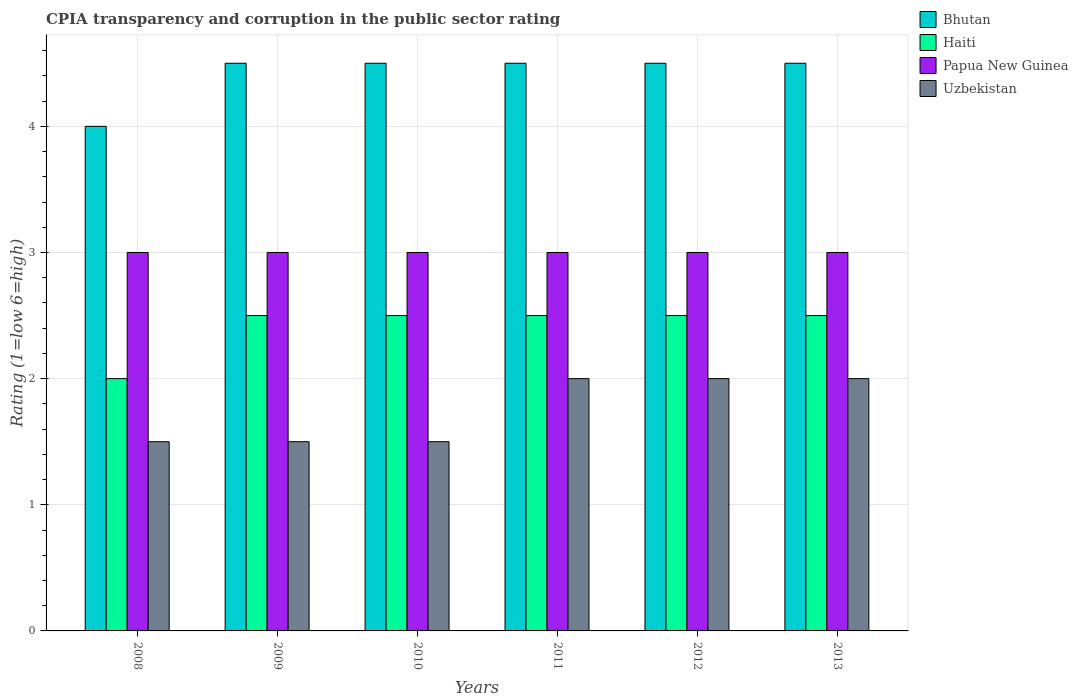How many groups of bars are there?
Provide a short and direct response. 6. Are the number of bars per tick equal to the number of legend labels?
Offer a very short reply. Yes. Are the number of bars on each tick of the X-axis equal?
Your answer should be very brief. Yes. How many bars are there on the 2nd tick from the left?
Provide a succinct answer. 4. How many bars are there on the 2nd tick from the right?
Your answer should be compact. 4. What is the label of the 2nd group of bars from the left?
Offer a terse response. 2009. In how many cases, is the number of bars for a given year not equal to the number of legend labels?
Ensure brevity in your answer.  0. What is the CPIA rating in Haiti in 2011?
Ensure brevity in your answer.  2.5. Across all years, what is the maximum CPIA rating in Bhutan?
Keep it short and to the point. 4.5. What is the total CPIA rating in Bhutan in the graph?
Ensure brevity in your answer.  26.5. What is the difference between the CPIA rating in Uzbekistan in 2011 and the CPIA rating in Bhutan in 2008?
Your response must be concise. -2. What is the average CPIA rating in Haiti per year?
Offer a very short reply. 2.42. In the year 2013, what is the difference between the CPIA rating in Bhutan and CPIA rating in Uzbekistan?
Give a very brief answer. 2.5. Is the CPIA rating in Haiti in 2011 less than that in 2013?
Offer a very short reply. No. What is the difference between the highest and the second highest CPIA rating in Uzbekistan?
Provide a succinct answer. 0. What is the difference between the highest and the lowest CPIA rating in Uzbekistan?
Ensure brevity in your answer.  0.5. In how many years, is the CPIA rating in Bhutan greater than the average CPIA rating in Bhutan taken over all years?
Provide a succinct answer. 5. What does the 1st bar from the left in 2012 represents?
Provide a short and direct response. Bhutan. What does the 3rd bar from the right in 2013 represents?
Your answer should be very brief. Haiti. Is it the case that in every year, the sum of the CPIA rating in Papua New Guinea and CPIA rating in Uzbekistan is greater than the CPIA rating in Haiti?
Offer a very short reply. Yes. How many bars are there?
Your response must be concise. 24. Does the graph contain any zero values?
Your response must be concise. No. Where does the legend appear in the graph?
Offer a terse response. Top right. What is the title of the graph?
Give a very brief answer. CPIA transparency and corruption in the public sector rating. What is the label or title of the Y-axis?
Make the answer very short. Rating (1=low 6=high). What is the Rating (1=low 6=high) of Bhutan in 2008?
Provide a succinct answer. 4. What is the Rating (1=low 6=high) of Haiti in 2008?
Make the answer very short. 2. What is the Rating (1=low 6=high) of Papua New Guinea in 2008?
Give a very brief answer. 3. What is the Rating (1=low 6=high) in Uzbekistan in 2008?
Offer a very short reply. 1.5. What is the Rating (1=low 6=high) of Bhutan in 2009?
Give a very brief answer. 4.5. What is the Rating (1=low 6=high) in Haiti in 2009?
Ensure brevity in your answer.  2.5. What is the Rating (1=low 6=high) of Papua New Guinea in 2009?
Offer a very short reply. 3. What is the Rating (1=low 6=high) of Uzbekistan in 2009?
Your answer should be very brief. 1.5. What is the Rating (1=low 6=high) in Papua New Guinea in 2010?
Your answer should be very brief. 3. What is the Rating (1=low 6=high) in Bhutan in 2011?
Give a very brief answer. 4.5. What is the Rating (1=low 6=high) in Haiti in 2011?
Your answer should be compact. 2.5. What is the Rating (1=low 6=high) in Bhutan in 2013?
Offer a very short reply. 4.5. What is the Rating (1=low 6=high) in Haiti in 2013?
Offer a very short reply. 2.5. Across all years, what is the maximum Rating (1=low 6=high) in Bhutan?
Provide a succinct answer. 4.5. Across all years, what is the maximum Rating (1=low 6=high) of Haiti?
Your answer should be compact. 2.5. Across all years, what is the maximum Rating (1=low 6=high) of Papua New Guinea?
Your answer should be compact. 3. Across all years, what is the minimum Rating (1=low 6=high) in Papua New Guinea?
Offer a terse response. 3. What is the total Rating (1=low 6=high) in Bhutan in the graph?
Ensure brevity in your answer.  26.5. What is the total Rating (1=low 6=high) in Papua New Guinea in the graph?
Offer a terse response. 18. What is the difference between the Rating (1=low 6=high) in Haiti in 2008 and that in 2009?
Ensure brevity in your answer.  -0.5. What is the difference between the Rating (1=low 6=high) in Uzbekistan in 2008 and that in 2009?
Provide a succinct answer. 0. What is the difference between the Rating (1=low 6=high) of Papua New Guinea in 2008 and that in 2010?
Offer a very short reply. 0. What is the difference between the Rating (1=low 6=high) in Uzbekistan in 2008 and that in 2010?
Keep it short and to the point. 0. What is the difference between the Rating (1=low 6=high) in Bhutan in 2008 and that in 2011?
Provide a succinct answer. -0.5. What is the difference between the Rating (1=low 6=high) in Haiti in 2008 and that in 2011?
Provide a short and direct response. -0.5. What is the difference between the Rating (1=low 6=high) in Haiti in 2008 and that in 2012?
Offer a very short reply. -0.5. What is the difference between the Rating (1=low 6=high) of Papua New Guinea in 2009 and that in 2010?
Make the answer very short. 0. What is the difference between the Rating (1=low 6=high) of Haiti in 2009 and that in 2011?
Keep it short and to the point. 0. What is the difference between the Rating (1=low 6=high) of Papua New Guinea in 2009 and that in 2011?
Ensure brevity in your answer.  0. What is the difference between the Rating (1=low 6=high) of Uzbekistan in 2009 and that in 2011?
Your answer should be very brief. -0.5. What is the difference between the Rating (1=low 6=high) in Bhutan in 2009 and that in 2012?
Ensure brevity in your answer.  0. What is the difference between the Rating (1=low 6=high) in Haiti in 2009 and that in 2012?
Offer a very short reply. 0. What is the difference between the Rating (1=low 6=high) of Papua New Guinea in 2009 and that in 2012?
Your answer should be very brief. 0. What is the difference between the Rating (1=low 6=high) of Bhutan in 2010 and that in 2011?
Your answer should be very brief. 0. What is the difference between the Rating (1=low 6=high) of Haiti in 2010 and that in 2011?
Your answer should be compact. 0. What is the difference between the Rating (1=low 6=high) of Uzbekistan in 2010 and that in 2011?
Provide a short and direct response. -0.5. What is the difference between the Rating (1=low 6=high) in Bhutan in 2010 and that in 2012?
Make the answer very short. 0. What is the difference between the Rating (1=low 6=high) in Uzbekistan in 2010 and that in 2012?
Offer a terse response. -0.5. What is the difference between the Rating (1=low 6=high) of Haiti in 2010 and that in 2013?
Your response must be concise. 0. What is the difference between the Rating (1=low 6=high) in Papua New Guinea in 2010 and that in 2013?
Your answer should be very brief. 0. What is the difference between the Rating (1=low 6=high) in Uzbekistan in 2010 and that in 2013?
Ensure brevity in your answer.  -0.5. What is the difference between the Rating (1=low 6=high) of Bhutan in 2011 and that in 2012?
Provide a short and direct response. 0. What is the difference between the Rating (1=low 6=high) of Haiti in 2011 and that in 2012?
Ensure brevity in your answer.  0. What is the difference between the Rating (1=low 6=high) in Uzbekistan in 2011 and that in 2012?
Give a very brief answer. 0. What is the difference between the Rating (1=low 6=high) in Bhutan in 2011 and that in 2013?
Offer a very short reply. 0. What is the difference between the Rating (1=low 6=high) in Haiti in 2011 and that in 2013?
Give a very brief answer. 0. What is the difference between the Rating (1=low 6=high) in Bhutan in 2012 and that in 2013?
Your answer should be compact. 0. What is the difference between the Rating (1=low 6=high) of Papua New Guinea in 2012 and that in 2013?
Your answer should be very brief. 0. What is the difference between the Rating (1=low 6=high) in Uzbekistan in 2012 and that in 2013?
Ensure brevity in your answer.  0. What is the difference between the Rating (1=low 6=high) of Bhutan in 2008 and the Rating (1=low 6=high) of Haiti in 2009?
Your answer should be very brief. 1.5. What is the difference between the Rating (1=low 6=high) of Bhutan in 2008 and the Rating (1=low 6=high) of Papua New Guinea in 2009?
Provide a succinct answer. 1. What is the difference between the Rating (1=low 6=high) in Haiti in 2008 and the Rating (1=low 6=high) in Papua New Guinea in 2009?
Make the answer very short. -1. What is the difference between the Rating (1=low 6=high) of Papua New Guinea in 2008 and the Rating (1=low 6=high) of Uzbekistan in 2009?
Ensure brevity in your answer.  1.5. What is the difference between the Rating (1=low 6=high) of Papua New Guinea in 2008 and the Rating (1=low 6=high) of Uzbekistan in 2010?
Keep it short and to the point. 1.5. What is the difference between the Rating (1=low 6=high) of Bhutan in 2008 and the Rating (1=low 6=high) of Uzbekistan in 2011?
Your answer should be very brief. 2. What is the difference between the Rating (1=low 6=high) in Papua New Guinea in 2008 and the Rating (1=low 6=high) in Uzbekistan in 2011?
Keep it short and to the point. 1. What is the difference between the Rating (1=low 6=high) in Bhutan in 2008 and the Rating (1=low 6=high) in Papua New Guinea in 2012?
Make the answer very short. 1. What is the difference between the Rating (1=low 6=high) in Bhutan in 2008 and the Rating (1=low 6=high) in Uzbekistan in 2012?
Offer a very short reply. 2. What is the difference between the Rating (1=low 6=high) of Haiti in 2008 and the Rating (1=low 6=high) of Papua New Guinea in 2012?
Your response must be concise. -1. What is the difference between the Rating (1=low 6=high) of Haiti in 2008 and the Rating (1=low 6=high) of Uzbekistan in 2012?
Offer a very short reply. 0. What is the difference between the Rating (1=low 6=high) of Papua New Guinea in 2008 and the Rating (1=low 6=high) of Uzbekistan in 2012?
Provide a succinct answer. 1. What is the difference between the Rating (1=low 6=high) of Bhutan in 2008 and the Rating (1=low 6=high) of Papua New Guinea in 2013?
Keep it short and to the point. 1. What is the difference between the Rating (1=low 6=high) of Papua New Guinea in 2008 and the Rating (1=low 6=high) of Uzbekistan in 2013?
Provide a short and direct response. 1. What is the difference between the Rating (1=low 6=high) of Bhutan in 2009 and the Rating (1=low 6=high) of Haiti in 2010?
Your response must be concise. 2. What is the difference between the Rating (1=low 6=high) of Bhutan in 2009 and the Rating (1=low 6=high) of Papua New Guinea in 2010?
Offer a very short reply. 1.5. What is the difference between the Rating (1=low 6=high) of Bhutan in 2009 and the Rating (1=low 6=high) of Uzbekistan in 2010?
Your response must be concise. 3. What is the difference between the Rating (1=low 6=high) of Haiti in 2009 and the Rating (1=low 6=high) of Uzbekistan in 2010?
Offer a very short reply. 1. What is the difference between the Rating (1=low 6=high) of Bhutan in 2009 and the Rating (1=low 6=high) of Haiti in 2011?
Your answer should be compact. 2. What is the difference between the Rating (1=low 6=high) in Haiti in 2009 and the Rating (1=low 6=high) in Papua New Guinea in 2011?
Offer a terse response. -0.5. What is the difference between the Rating (1=low 6=high) in Haiti in 2009 and the Rating (1=low 6=high) in Uzbekistan in 2012?
Your response must be concise. 0.5. What is the difference between the Rating (1=low 6=high) of Bhutan in 2009 and the Rating (1=low 6=high) of Uzbekistan in 2013?
Your response must be concise. 2.5. What is the difference between the Rating (1=low 6=high) of Papua New Guinea in 2009 and the Rating (1=low 6=high) of Uzbekistan in 2013?
Your answer should be compact. 1. What is the difference between the Rating (1=low 6=high) of Bhutan in 2010 and the Rating (1=low 6=high) of Haiti in 2011?
Make the answer very short. 2. What is the difference between the Rating (1=low 6=high) in Haiti in 2010 and the Rating (1=low 6=high) in Papua New Guinea in 2011?
Make the answer very short. -0.5. What is the difference between the Rating (1=low 6=high) in Haiti in 2010 and the Rating (1=low 6=high) in Uzbekistan in 2011?
Offer a very short reply. 0.5. What is the difference between the Rating (1=low 6=high) in Papua New Guinea in 2010 and the Rating (1=low 6=high) in Uzbekistan in 2011?
Your answer should be compact. 1. What is the difference between the Rating (1=low 6=high) of Bhutan in 2010 and the Rating (1=low 6=high) of Haiti in 2012?
Your answer should be compact. 2. What is the difference between the Rating (1=low 6=high) of Haiti in 2010 and the Rating (1=low 6=high) of Uzbekistan in 2012?
Provide a succinct answer. 0.5. What is the difference between the Rating (1=low 6=high) of Bhutan in 2010 and the Rating (1=low 6=high) of Haiti in 2013?
Make the answer very short. 2. What is the difference between the Rating (1=low 6=high) of Haiti in 2010 and the Rating (1=low 6=high) of Papua New Guinea in 2013?
Provide a succinct answer. -0.5. What is the difference between the Rating (1=low 6=high) of Haiti in 2010 and the Rating (1=low 6=high) of Uzbekistan in 2013?
Provide a short and direct response. 0.5. What is the difference between the Rating (1=low 6=high) in Papua New Guinea in 2010 and the Rating (1=low 6=high) in Uzbekistan in 2013?
Keep it short and to the point. 1. What is the difference between the Rating (1=low 6=high) in Bhutan in 2011 and the Rating (1=low 6=high) in Haiti in 2012?
Your answer should be very brief. 2. What is the difference between the Rating (1=low 6=high) of Haiti in 2011 and the Rating (1=low 6=high) of Papua New Guinea in 2012?
Offer a terse response. -0.5. What is the difference between the Rating (1=low 6=high) of Papua New Guinea in 2011 and the Rating (1=low 6=high) of Uzbekistan in 2012?
Provide a succinct answer. 1. What is the difference between the Rating (1=low 6=high) of Bhutan in 2011 and the Rating (1=low 6=high) of Papua New Guinea in 2013?
Your answer should be very brief. 1.5. What is the difference between the Rating (1=low 6=high) of Haiti in 2011 and the Rating (1=low 6=high) of Papua New Guinea in 2013?
Your answer should be very brief. -0.5. What is the difference between the Rating (1=low 6=high) in Bhutan in 2012 and the Rating (1=low 6=high) in Haiti in 2013?
Your answer should be very brief. 2. What is the difference between the Rating (1=low 6=high) in Bhutan in 2012 and the Rating (1=low 6=high) in Uzbekistan in 2013?
Ensure brevity in your answer.  2.5. What is the difference between the Rating (1=low 6=high) in Papua New Guinea in 2012 and the Rating (1=low 6=high) in Uzbekistan in 2013?
Offer a very short reply. 1. What is the average Rating (1=low 6=high) in Bhutan per year?
Provide a succinct answer. 4.42. What is the average Rating (1=low 6=high) in Haiti per year?
Provide a short and direct response. 2.42. In the year 2008, what is the difference between the Rating (1=low 6=high) in Bhutan and Rating (1=low 6=high) in Haiti?
Ensure brevity in your answer.  2. In the year 2008, what is the difference between the Rating (1=low 6=high) of Bhutan and Rating (1=low 6=high) of Papua New Guinea?
Provide a short and direct response. 1. In the year 2009, what is the difference between the Rating (1=low 6=high) in Bhutan and Rating (1=low 6=high) in Haiti?
Ensure brevity in your answer.  2. In the year 2009, what is the difference between the Rating (1=low 6=high) of Bhutan and Rating (1=low 6=high) of Papua New Guinea?
Offer a terse response. 1.5. In the year 2009, what is the difference between the Rating (1=low 6=high) in Bhutan and Rating (1=low 6=high) in Uzbekistan?
Your answer should be compact. 3. In the year 2009, what is the difference between the Rating (1=low 6=high) in Papua New Guinea and Rating (1=low 6=high) in Uzbekistan?
Give a very brief answer. 1.5. In the year 2010, what is the difference between the Rating (1=low 6=high) in Bhutan and Rating (1=low 6=high) in Papua New Guinea?
Keep it short and to the point. 1.5. In the year 2010, what is the difference between the Rating (1=low 6=high) of Bhutan and Rating (1=low 6=high) of Uzbekistan?
Your answer should be very brief. 3. In the year 2010, what is the difference between the Rating (1=low 6=high) in Haiti and Rating (1=low 6=high) in Papua New Guinea?
Your answer should be compact. -0.5. In the year 2010, what is the difference between the Rating (1=low 6=high) of Haiti and Rating (1=low 6=high) of Uzbekistan?
Provide a succinct answer. 1. In the year 2011, what is the difference between the Rating (1=low 6=high) of Bhutan and Rating (1=low 6=high) of Uzbekistan?
Provide a succinct answer. 2.5. In the year 2011, what is the difference between the Rating (1=low 6=high) in Haiti and Rating (1=low 6=high) in Papua New Guinea?
Offer a very short reply. -0.5. In the year 2011, what is the difference between the Rating (1=low 6=high) of Papua New Guinea and Rating (1=low 6=high) of Uzbekistan?
Provide a short and direct response. 1. In the year 2012, what is the difference between the Rating (1=low 6=high) in Bhutan and Rating (1=low 6=high) in Haiti?
Provide a succinct answer. 2. In the year 2012, what is the difference between the Rating (1=low 6=high) in Bhutan and Rating (1=low 6=high) in Papua New Guinea?
Offer a very short reply. 1.5. In the year 2012, what is the difference between the Rating (1=low 6=high) in Haiti and Rating (1=low 6=high) in Papua New Guinea?
Your response must be concise. -0.5. In the year 2013, what is the difference between the Rating (1=low 6=high) in Bhutan and Rating (1=low 6=high) in Uzbekistan?
Your response must be concise. 2.5. In the year 2013, what is the difference between the Rating (1=low 6=high) in Haiti and Rating (1=low 6=high) in Uzbekistan?
Make the answer very short. 0.5. What is the ratio of the Rating (1=low 6=high) of Bhutan in 2008 to that in 2009?
Your response must be concise. 0.89. What is the ratio of the Rating (1=low 6=high) of Uzbekistan in 2008 to that in 2009?
Your response must be concise. 1. What is the ratio of the Rating (1=low 6=high) in Haiti in 2008 to that in 2010?
Give a very brief answer. 0.8. What is the ratio of the Rating (1=low 6=high) of Bhutan in 2008 to that in 2011?
Ensure brevity in your answer.  0.89. What is the ratio of the Rating (1=low 6=high) in Bhutan in 2008 to that in 2012?
Your answer should be very brief. 0.89. What is the ratio of the Rating (1=low 6=high) of Haiti in 2008 to that in 2012?
Your response must be concise. 0.8. What is the ratio of the Rating (1=low 6=high) of Papua New Guinea in 2008 to that in 2013?
Offer a terse response. 1. What is the ratio of the Rating (1=low 6=high) in Uzbekistan in 2008 to that in 2013?
Your answer should be very brief. 0.75. What is the ratio of the Rating (1=low 6=high) of Papua New Guinea in 2009 to that in 2011?
Keep it short and to the point. 1. What is the ratio of the Rating (1=low 6=high) of Bhutan in 2009 to that in 2012?
Ensure brevity in your answer.  1. What is the ratio of the Rating (1=low 6=high) of Uzbekistan in 2009 to that in 2012?
Make the answer very short. 0.75. What is the ratio of the Rating (1=low 6=high) of Bhutan in 2009 to that in 2013?
Provide a short and direct response. 1. What is the ratio of the Rating (1=low 6=high) in Papua New Guinea in 2009 to that in 2013?
Offer a terse response. 1. What is the ratio of the Rating (1=low 6=high) in Bhutan in 2010 to that in 2011?
Offer a very short reply. 1. What is the ratio of the Rating (1=low 6=high) of Uzbekistan in 2010 to that in 2011?
Provide a short and direct response. 0.75. What is the ratio of the Rating (1=low 6=high) in Bhutan in 2010 to that in 2012?
Offer a terse response. 1. What is the ratio of the Rating (1=low 6=high) in Uzbekistan in 2010 to that in 2012?
Make the answer very short. 0.75. What is the ratio of the Rating (1=low 6=high) in Papua New Guinea in 2010 to that in 2013?
Your response must be concise. 1. What is the ratio of the Rating (1=low 6=high) of Bhutan in 2011 to that in 2012?
Your answer should be compact. 1. What is the ratio of the Rating (1=low 6=high) in Bhutan in 2011 to that in 2013?
Make the answer very short. 1. What is the ratio of the Rating (1=low 6=high) of Papua New Guinea in 2011 to that in 2013?
Make the answer very short. 1. What is the ratio of the Rating (1=low 6=high) in Haiti in 2012 to that in 2013?
Offer a very short reply. 1. What is the difference between the highest and the second highest Rating (1=low 6=high) of Uzbekistan?
Offer a terse response. 0. What is the difference between the highest and the lowest Rating (1=low 6=high) in Haiti?
Provide a short and direct response. 0.5. What is the difference between the highest and the lowest Rating (1=low 6=high) in Uzbekistan?
Ensure brevity in your answer.  0.5. 